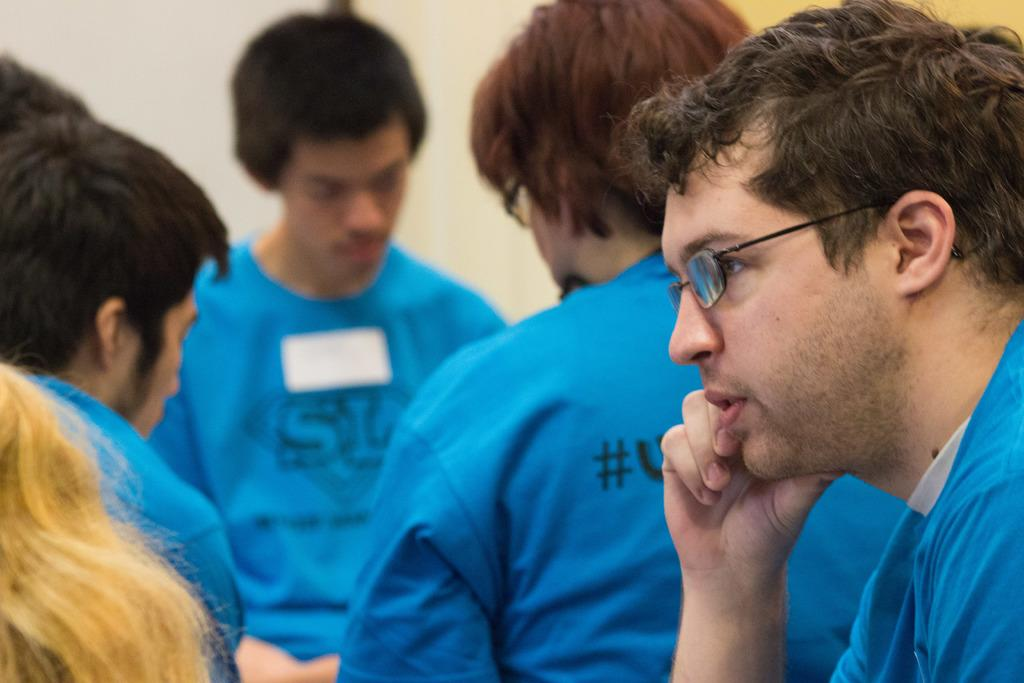What are the men in the foreground of the image wearing? The men in the foreground of the image are wearing blue T-shirts. Can you describe the woman in the image? There is a woman with blonde hair in the left bottom corner of the image. What can be seen in the background of the image? There is a wall in the background of the image. What type of honey is being served on the ship in the image? There is no ship or honey present in the image. How does the tramp interact with the woman in the image? There is no tramp present in the image; it only features men in blue T-shirts and a woman with blonde hair. 